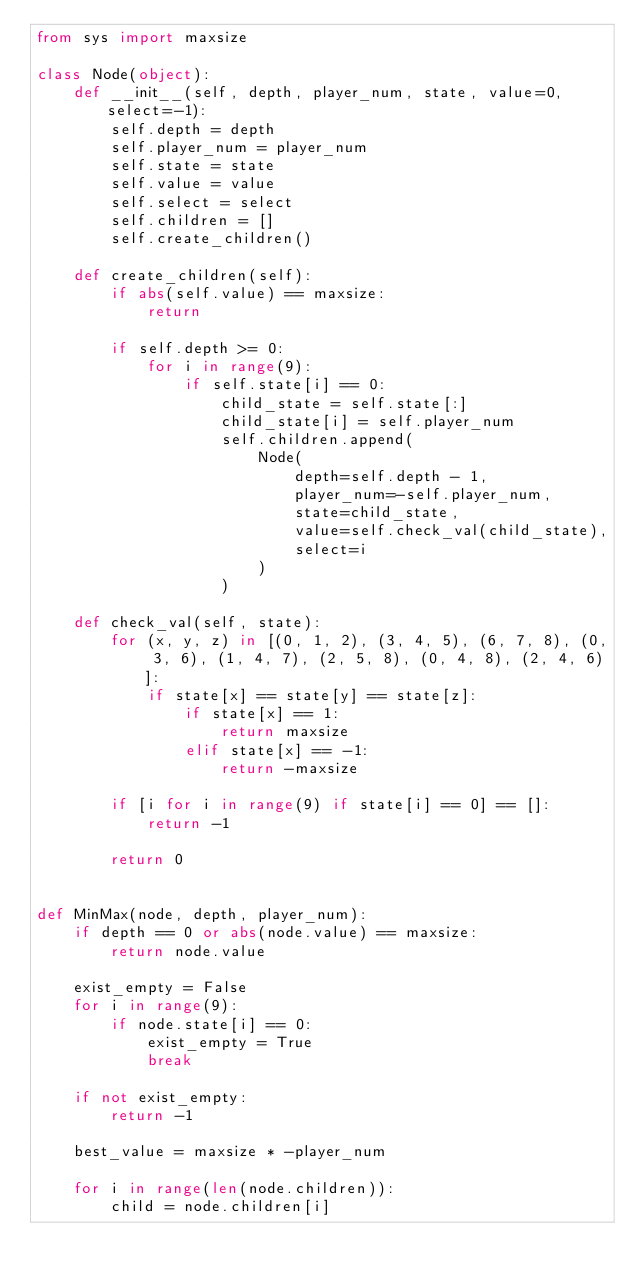Convert code to text. <code><loc_0><loc_0><loc_500><loc_500><_Python_>from sys import maxsize

class Node(object):
    def __init__(self, depth, player_num, state, value=0, select=-1):
        self.depth = depth
        self.player_num = player_num
        self.state = state
        self.value = value
        self.select = select
        self.children = []
        self.create_children()

    def create_children(self):
        if abs(self.value) == maxsize:
            return

        if self.depth >= 0:
            for i in range(9):
                if self.state[i] == 0:
                    child_state = self.state[:]
                    child_state[i] = self.player_num
                    self.children.append(
                        Node(
                            depth=self.depth - 1,
                            player_num=-self.player_num,
                            state=child_state,
                            value=self.check_val(child_state),
                            select=i
                        )
                    )

    def check_val(self, state):
        for (x, y, z) in [(0, 1, 2), (3, 4, 5), (6, 7, 8), (0, 3, 6), (1, 4, 7), (2, 5, 8), (0, 4, 8), (2, 4, 6)]:
            if state[x] == state[y] == state[z]:
                if state[x] == 1:
                    return maxsize
                elif state[x] == -1:
                    return -maxsize

        if [i for i in range(9) if state[i] == 0] == []:
            return -1

        return 0


def MinMax(node, depth, player_num):
    if depth == 0 or abs(node.value) == maxsize:
        return node.value

    exist_empty = False
    for i in range(9):
        if node.state[i] == 0:
            exist_empty = True
            break

    if not exist_empty:
        return -1

    best_value = maxsize * -player_num

    for i in range(len(node.children)):
        child = node.children[i]</code> 